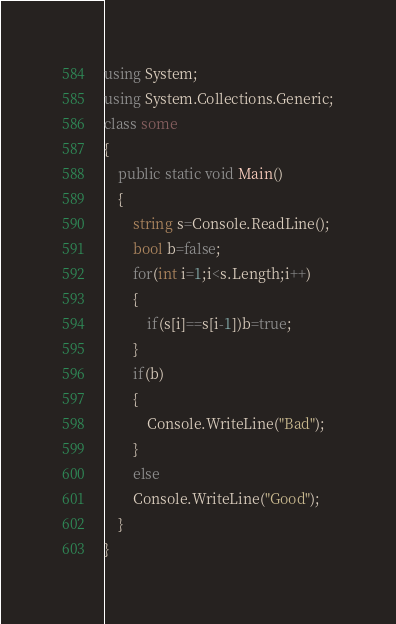<code> <loc_0><loc_0><loc_500><loc_500><_C#_>using System;
using System.Collections.Generic;
class some
{
	public static void Main()
	{
		string s=Console.ReadLine();
		bool b=false;
		for(int i=1;i<s.Length;i++)
		{
			if(s[i]==s[i-1])b=true;
		}
		if(b)
		{
			Console.WriteLine("Bad");
		}
		else
		Console.WriteLine("Good");
	}
}</code> 